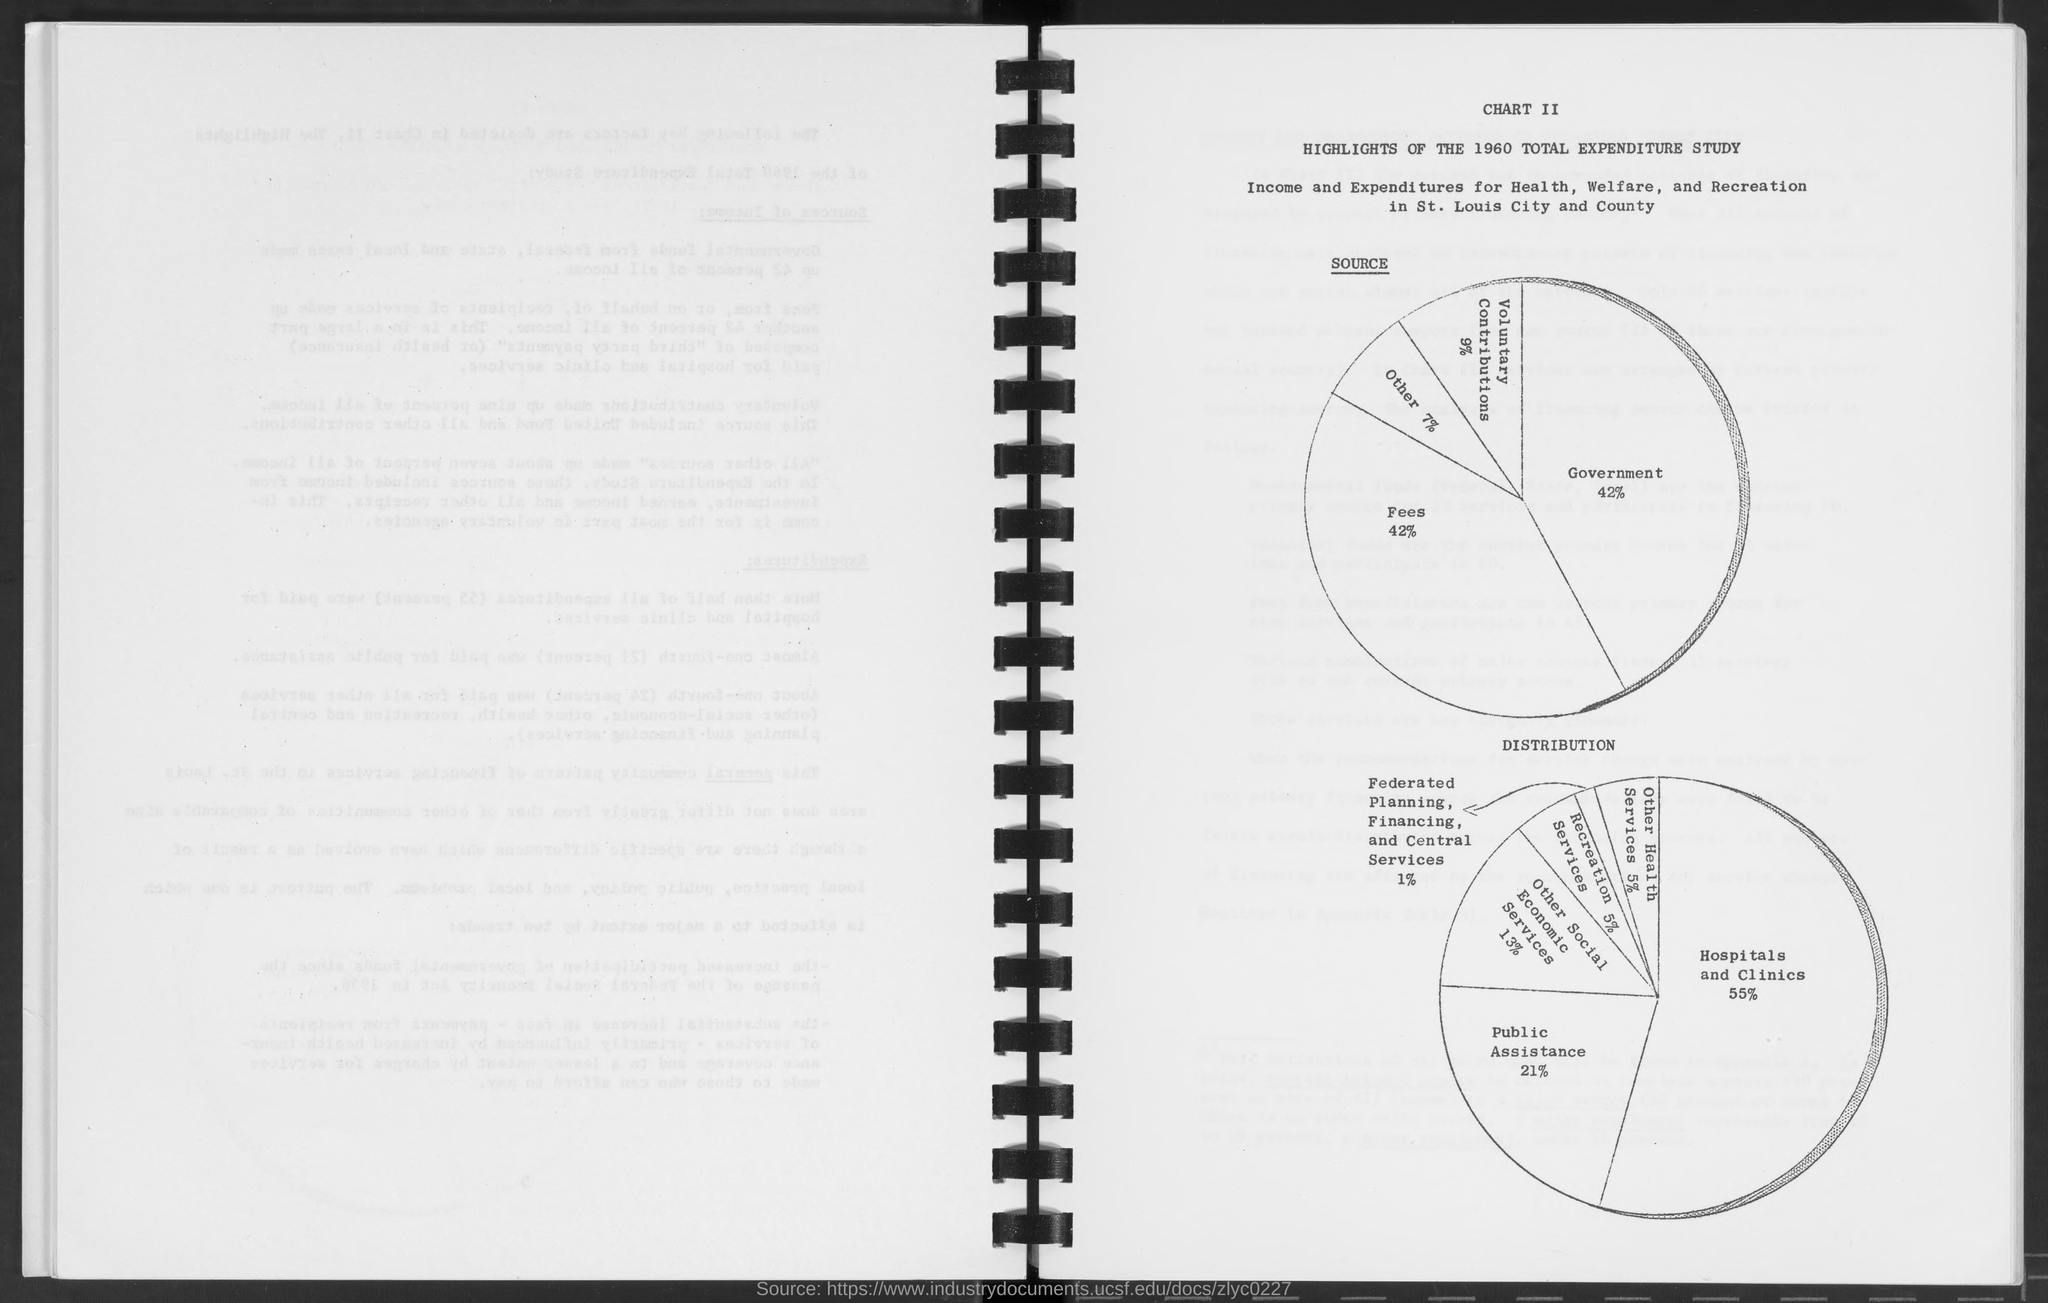Aside from government sources, what other income sources support the Health, Welfare, and Recreation expenses? In addition to the government contributions, which make up 42% as mentioned, fees constitute an equal portion of 42% of the income for Health, Welfare, and Recreation expenses. The remaining 16% comes from other sources, as indicated on the pie chart. 